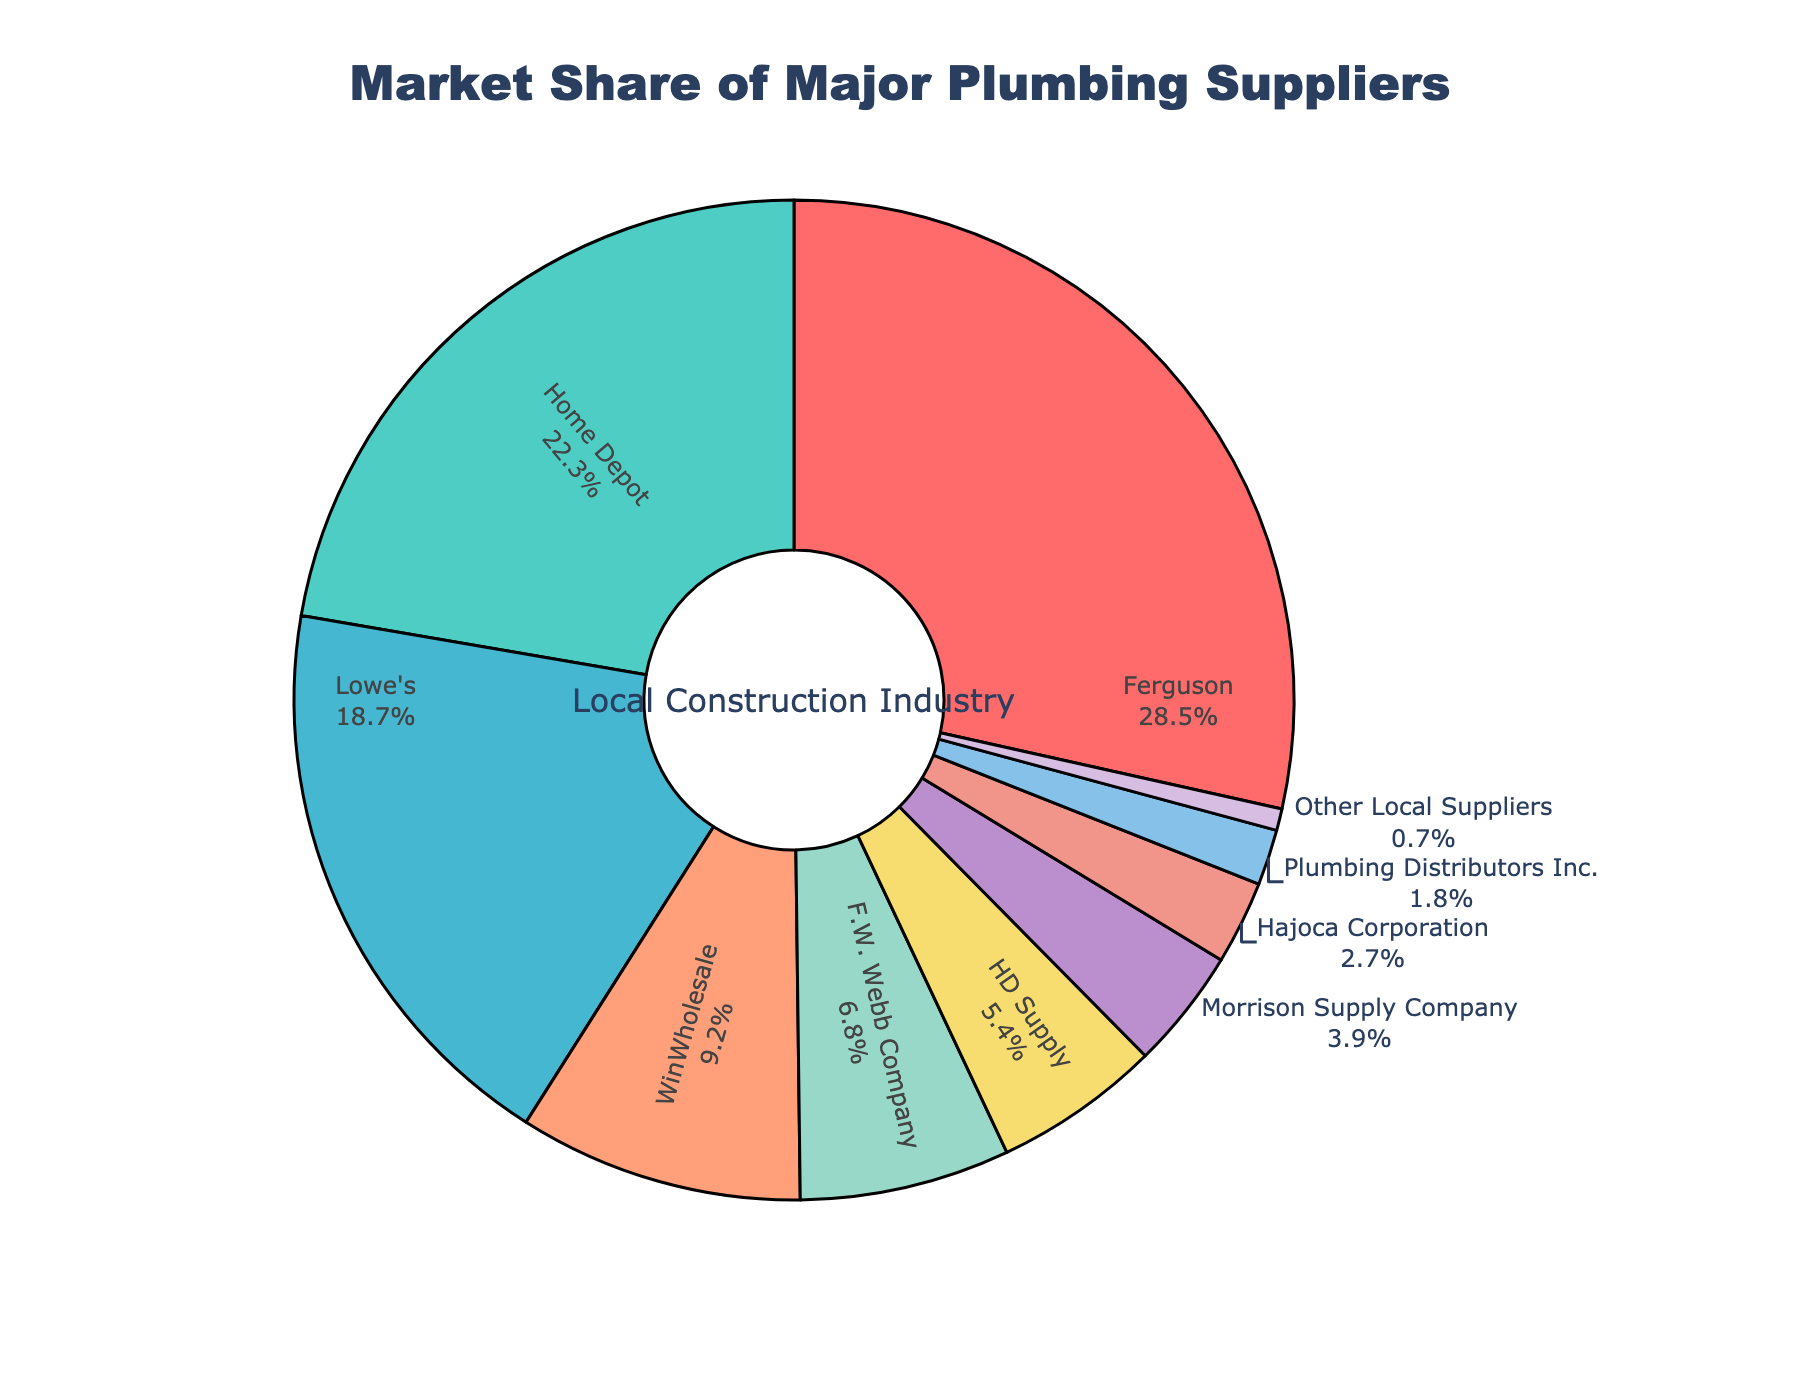Which supplier holds the largest market share? By inspecting the slice sizes in the pie chart, the largest slice is attributed to Ferguson with a market share of 28.5%.
Answer: Ferguson Which supplier has the smallest market share? The smallest slice in the pie chart belongs to Other Local Suppliers with a market share of 0.7%.
Answer: Other Local Suppliers What's the combined market share of Home Depot and Lowe's? The market share for Home Depot is 22.3% and for Lowe's is 18.7%. Adding these together, 22.3 + 18.7 = 41.0%.
Answer: 41.0% How does the market share of Morrison Supply Company compare to Hajoca Corporation? Morrison Supply Company has a market share of 3.9%, while Hajoca Corporation has 2.7%. Therefore, Morrison Supply Company has a higher market share.
Answer: Morrison Supply Company has a higher market share What is the average market share of Ferguson, Home Depot, and Lowe's? To find the average, add the market shares of Ferguson (28.5%), Home Depot (22.3%), and Lowe's (18.7%), then divide by 3: (28.5 + 22.3 + 18.7) / 3 = 23.17%.
Answer: 23.17% What is the color of the slice representing HD Supply? The pie chart shows the slice for HD Supply colored in a greenish shade.
Answer: greenish How much more market share does WinWholesale have compared to Plumbing Distributors Inc.? WinWholesale has a market share of 9.2%, and Plumbing Distributors Inc. has 1.8%. Subtract the smaller from the larger: 9.2 - 1.8 = 7.4%.
Answer: 7.4% Which suppliers together hold more than half of the market share? Ferguson (28.5%) and Home Depot (22.3%) combined have a total market share of 50.8%. Since this exceeds 50%, together they hold more than half of the market share.
Answer: Ferguson and Home Depot If you exclude the top three suppliers, what percentage of the market share do the remaining suppliers hold? Adding the top three suppliers' market shares: Ferguson (28.5%), Home Depot (22.3%), and Lowe's (18.7%) = 69.5%. Subtract this from 100% to get 100 - 69.5 = 30.5%.
Answer: 30.5% 